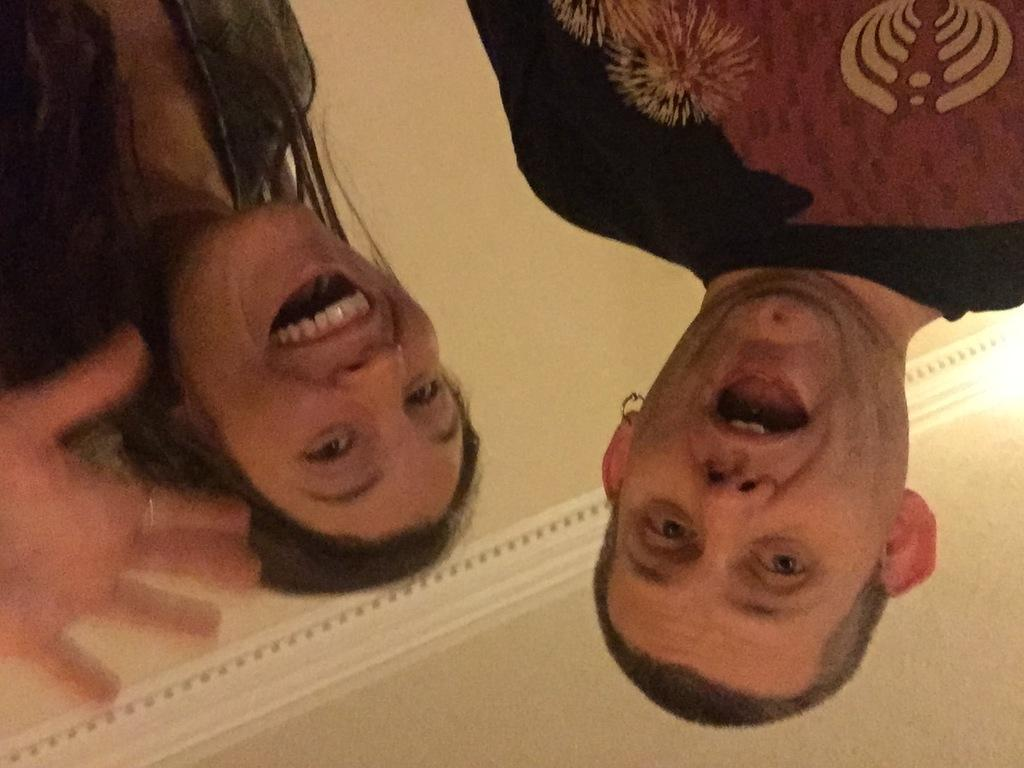Who are the people in the image? There is a man and a woman in the image. What are the man and woman doing in the image? The facts provided do not specify what the man and woman are doing in the image. Can you describe the clothing of the man and woman in the image? The facts provided do not specify the clothing of the man and woman in the image. How many tomatoes are on the table in the image? There is no table or tomatoes present in the image; it only features a man and a woman. What type of game are the man and woman playing in the image? There is no game being played in the image; it only features a man and a woman. 